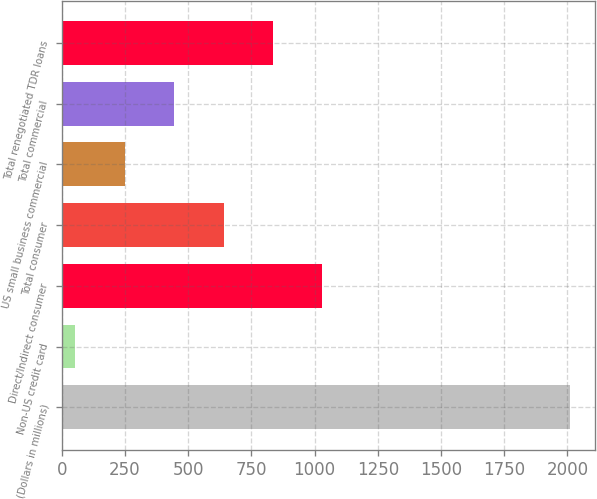Convert chart to OTSL. <chart><loc_0><loc_0><loc_500><loc_500><bar_chart><fcel>(Dollars in millions)<fcel>Non-US credit card<fcel>Direct/Indirect consumer<fcel>Total consumer<fcel>US small business commercial<fcel>Total commercial<fcel>Total renegotiated TDR loans<nl><fcel>2009<fcel>53.02<fcel>1031.02<fcel>639.82<fcel>248.62<fcel>444.22<fcel>835.42<nl></chart> 